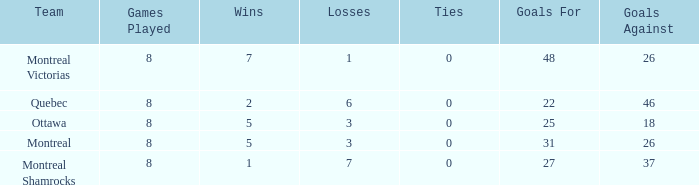Would you be able to parse every entry in this table? {'header': ['Team', 'Games Played', 'Wins', 'Losses', 'Ties', 'Goals For', 'Goals Against'], 'rows': [['Montreal Victorias', '8', '7', '1', '0', '48', '26'], ['Quebec', '8', '2', '6', '0', '22', '46'], ['Ottawa', '8', '5', '3', '0', '25', '18'], ['Montreal', '8', '5', '3', '0', '31', '26'], ['Montreal Shamrocks', '8', '1', '7', '0', '27', '37']]} For teams with more than 0 ties and goals against of 37, how many wins were tallied? None. 